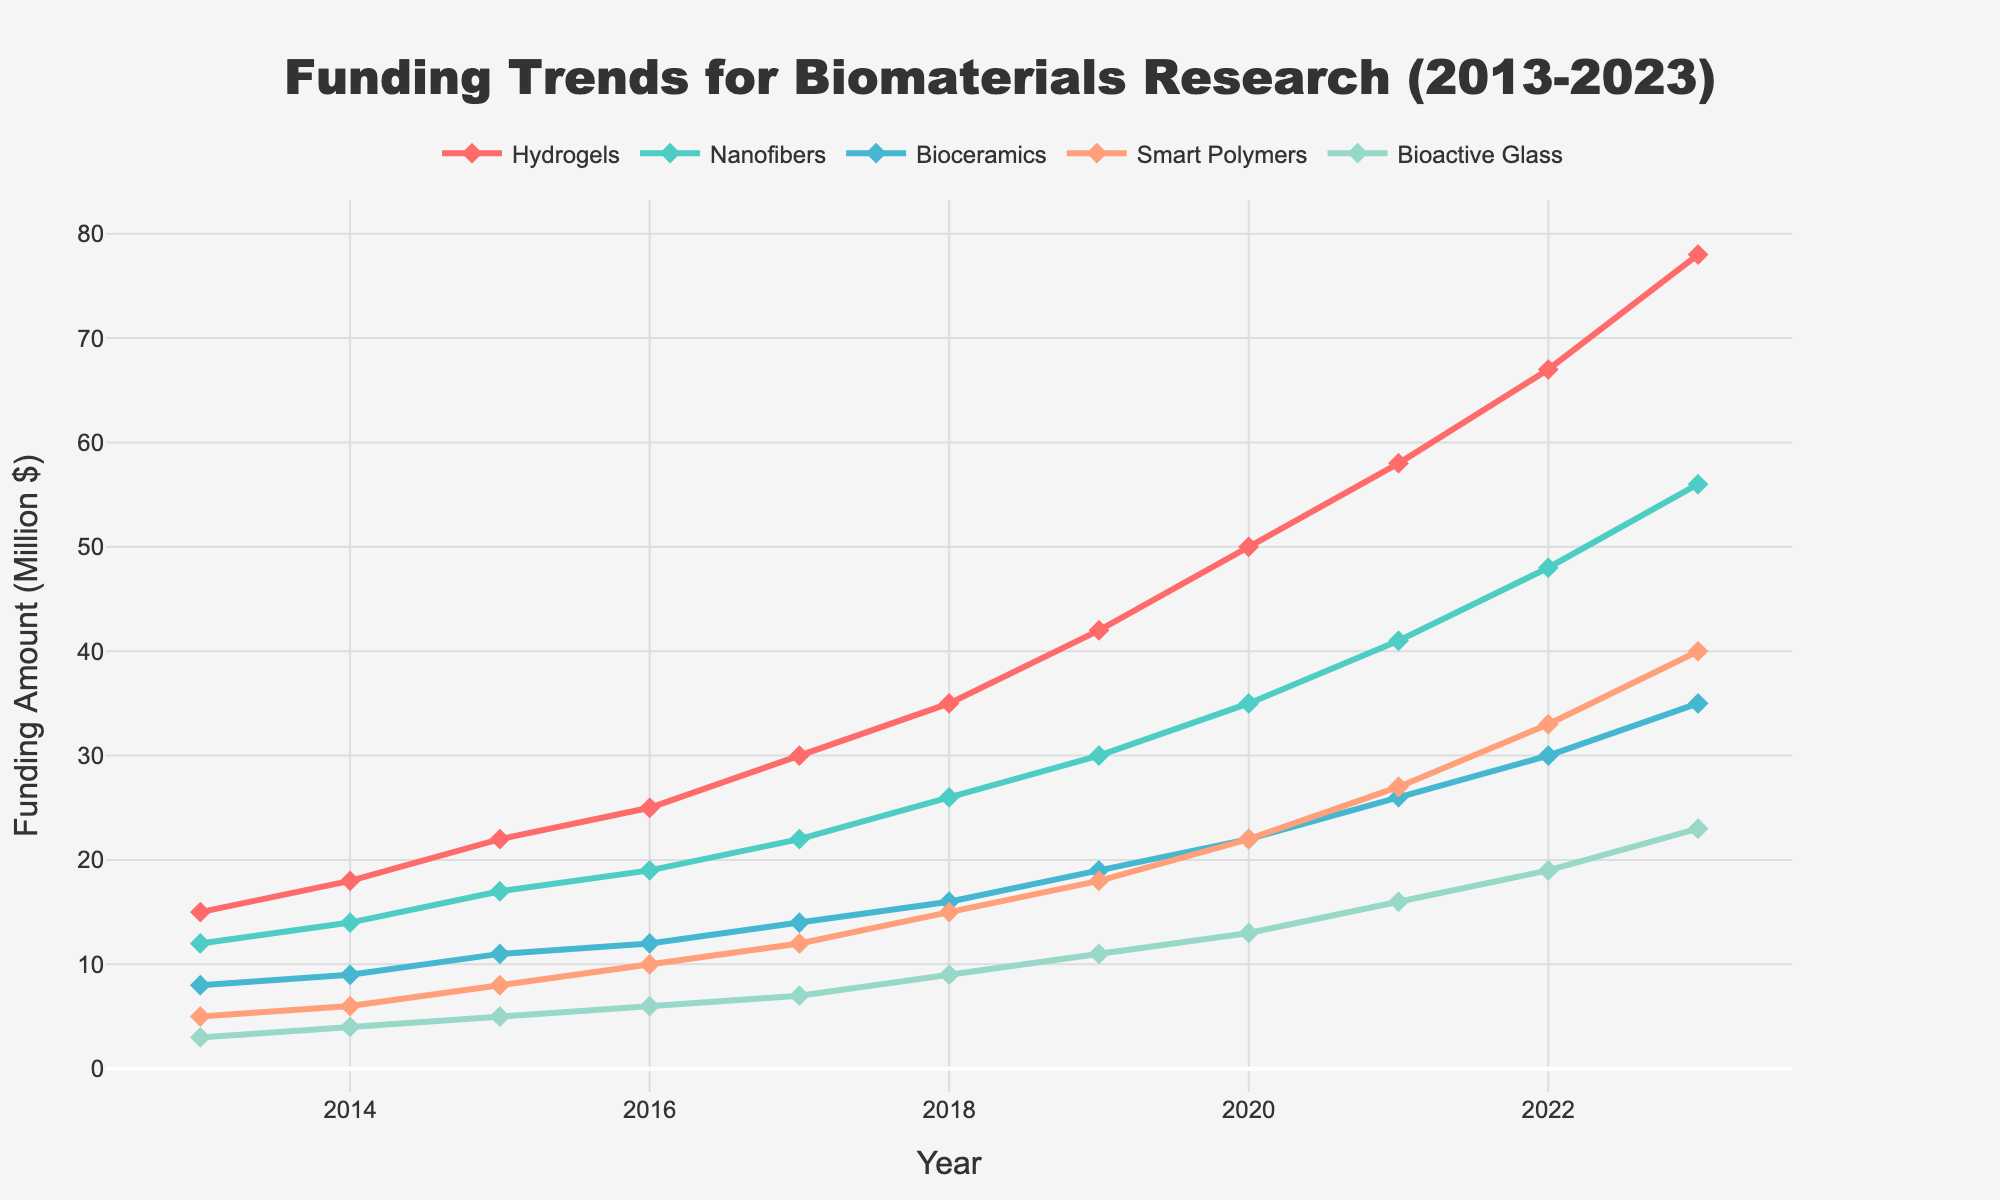What's the funding difference between Hydrogels and Nanofibers in 2023? In 2023, the funding for Hydrogels is 78 million dollars, and for Nanofibers, it is 56 million dollars. The difference is 78 - 56 = 22 million dollars.
Answer: 22 million dollars Which material type had the highest funding in 2018? In 2018, the funding amounts for the material types are: Hydrogels (35), Nanofibers (26), Bioceramics (16), Smart Polymers (15), Bioactive Glass (9). Hydrogels had the highest funding.
Answer: Hydrogels What is the median funding for Bioactive Glass over the decade? The funding amounts for Bioactive Glass over the years are: 3, 4, 5, 6, 7, 9, 11, 13, 16, 19, 23. The median of these 11 values is the 6th value when sorted, which is 9 million dollars.
Answer: 9 million dollars How did the funding for Smart Polymers change from 2015 to 2018? In 2015, the funding for Smart Polymers was 8 million dollars. In 2018, it was 15 million dollars. The change is 15 - 8 = 7 million dollars.
Answer: Increased by 7 million dollars Which material had the least increase in funding from 2013 to 2023? Calculating the increase for each material:
- Hydrogels: 78 - 15 = 63
- Nanofibers: 56 - 12 = 44
- Bioceramics: 35 - 8 = 27
- Smart Polymers: 40 - 5 = 35
- Bioactive Glass: 23 - 3 = 20
Bioactive Glass had the least increase with 20 million dollars.
Answer: Bioactive Glass What was the total funding for all materials in the year 2021? Summing up the funding for all materials in 2021: 58 (Hydrogels) + 41 (Nanofibers) + 26 (Bioceramics) + 27 (Smart Polymers) + 16 (Bioactive Glass) = 168 million dollars.
Answer: 168 million dollars Did any material type experience a steady year-over-year increase in funding? Looking at the funding data year-on-year for each material type:
- Hydrogels: Consistently increasing each year
- Nanofibers: Consistently increasing each year
- Bioceramics: Consistently increasing each year
- Smart Polymers: Consistently increasing each year
- Bioactive Glass: Consistently increasing each year
All material types show a steady year-over-year increase.
Answer: Yes, all material types How does the funding trend for Bioceramics compare with that of Smart Polymers over the decade? Analyzing the trends shown: Both Bioceramics and Smart Polymers exhibit a positive trend over the decade. However, Smart Polymers saw a sharper rise in recent years, surpassing Bioceramics around 2017, and continue to rise at a faster rate.
Answer: Smart Polymers increased faster than Bioceramics What was the average annual funding for Nanofibers between 2013 and 2023? The funding amounts are: 12, 14, 17, 19, 22, 26, 30, 35, 41, 48, 56. Summing these and dividing by 11 years: (12 + 14 + 17 + 19 + 22 + 26 + 30 + 35 + 41 + 48 + 56) / 11 = 29 million dollars.
Answer: 29 million dollars 